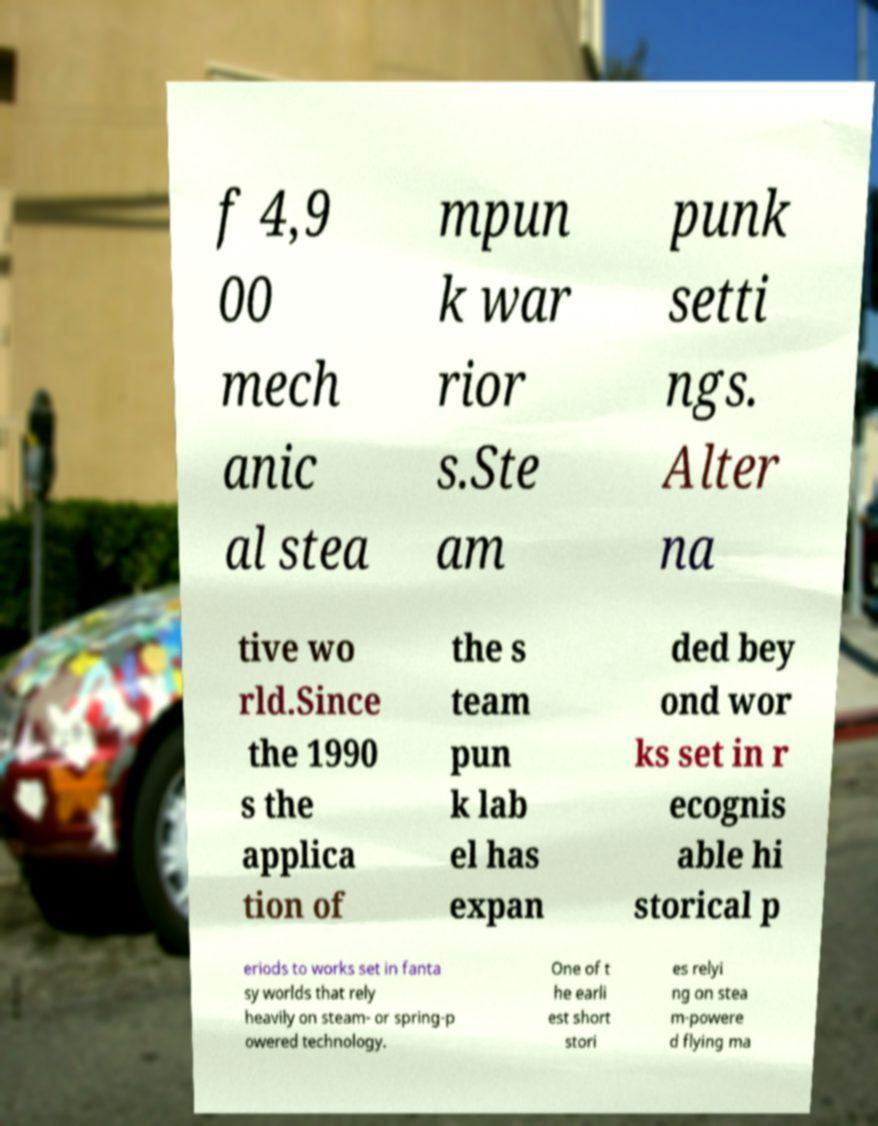Please read and relay the text visible in this image. What does it say? f 4,9 00 mech anic al stea mpun k war rior s.Ste am punk setti ngs. Alter na tive wo rld.Since the 1990 s the applica tion of the s team pun k lab el has expan ded bey ond wor ks set in r ecognis able hi storical p eriods to works set in fanta sy worlds that rely heavily on steam- or spring-p owered technology. One of t he earli est short stori es relyi ng on stea m-powere d flying ma 